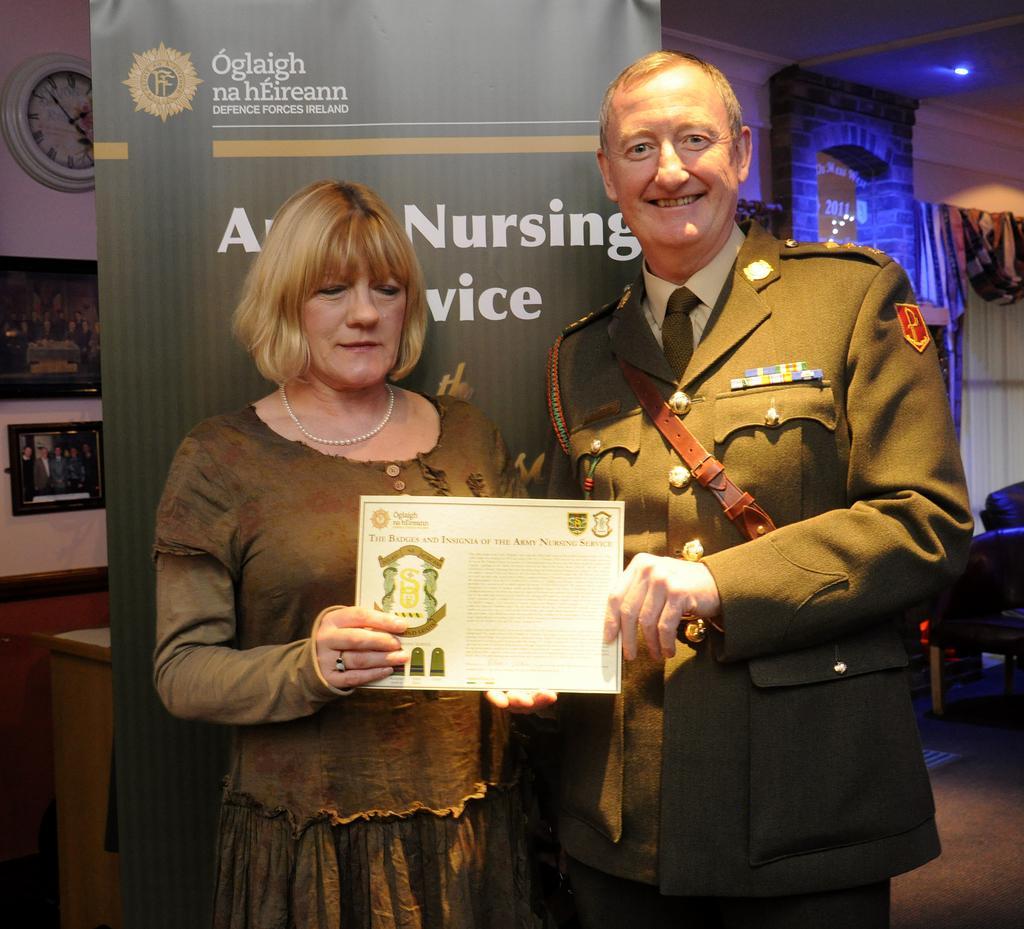Please provide a concise description of this image. In this image I can see two persons are standing on the floor and are holding a certificate in hand. In the background I can see a poster, chairs, photo frames and a clock on a wall. This image is taken may be in a hall. 